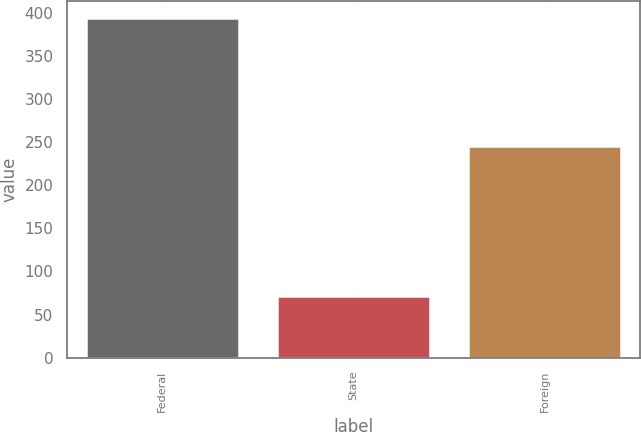Convert chart. <chart><loc_0><loc_0><loc_500><loc_500><bar_chart><fcel>Federal<fcel>State<fcel>Foreign<nl><fcel>394<fcel>71<fcel>245<nl></chart> 